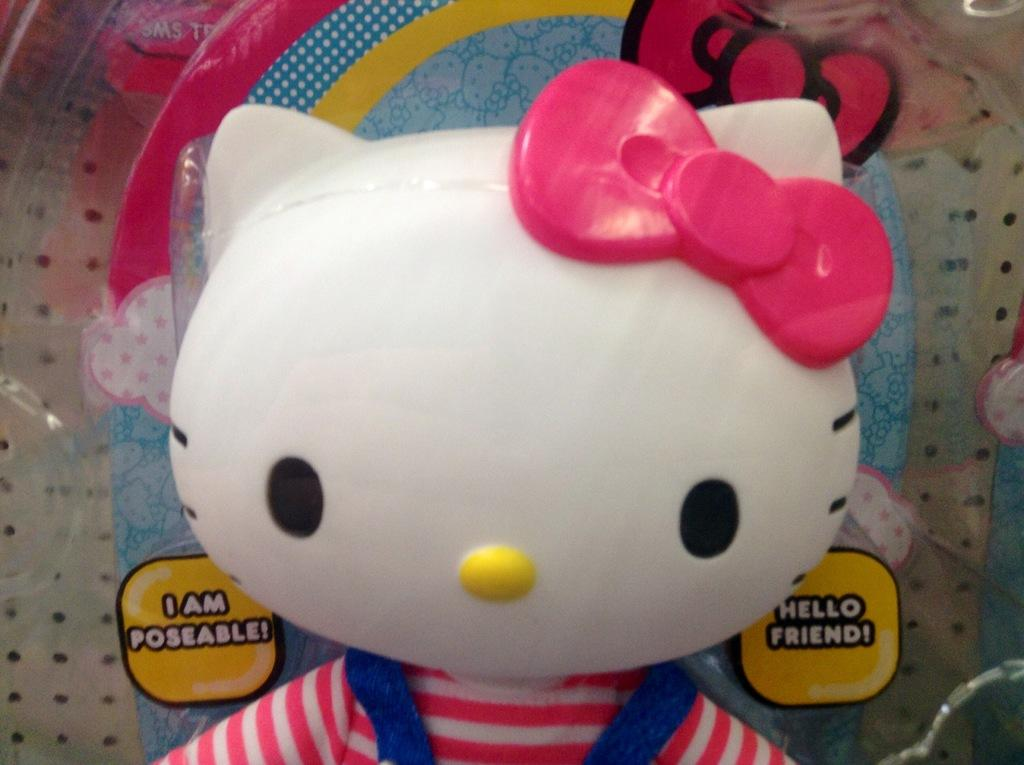What is the main subject of the picture? There is a toy in the picture. Are there any other objects in the picture besides the toy? Yes, there are other objects in the picture. Can you describe something written on an object in the background of the image? Unfortunately, the facts provided do not give enough information to describe what is written on an object in the background. How many brothers are playing with the marble in the image? There is no marble or brothers present in the image. What type of test is being conducted in the image? There is no test being conducted in the image. 